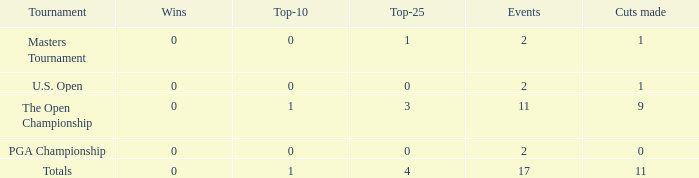What is his low win total when he has over 3 top 25s and under 9 cuts made? None. Give me the full table as a dictionary. {'header': ['Tournament', 'Wins', 'Top-10', 'Top-25', 'Events', 'Cuts made'], 'rows': [['Masters Tournament', '0', '0', '1', '2', '1'], ['U.S. Open', '0', '0', '0', '2', '1'], ['The Open Championship', '0', '1', '3', '11', '9'], ['PGA Championship', '0', '0', '0', '2', '0'], ['Totals', '0', '1', '4', '17', '11']]} 